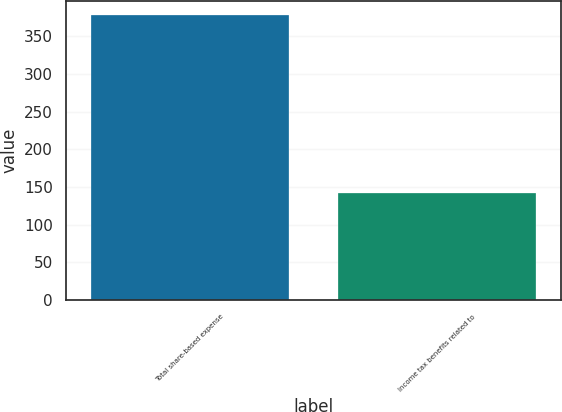Convert chart to OTSL. <chart><loc_0><loc_0><loc_500><loc_500><bar_chart><fcel>Total share-based expense<fcel>Income tax benefits related to<nl><fcel>378<fcel>142<nl></chart> 